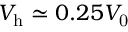Convert formula to latex. <formula><loc_0><loc_0><loc_500><loc_500>V _ { h } \simeq 0 . 2 5 V _ { 0 }</formula> 